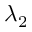<formula> <loc_0><loc_0><loc_500><loc_500>\lambda _ { 2 }</formula> 